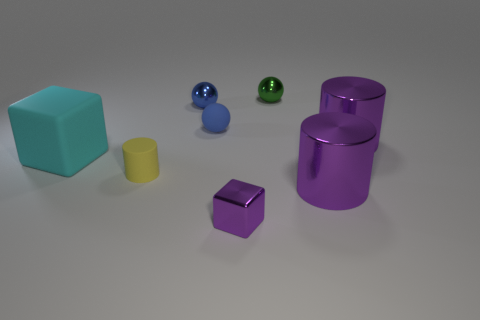Subtract all large purple cylinders. How many cylinders are left? 1 Subtract all blue balls. How many balls are left? 1 Add 1 large objects. How many objects exist? 9 Subtract all green cylinders. How many cyan cubes are left? 1 Subtract all small blue rubber spheres. Subtract all green shiny balls. How many objects are left? 6 Add 8 blue balls. How many blue balls are left? 10 Add 1 large metallic cylinders. How many large metallic cylinders exist? 3 Subtract 1 purple cubes. How many objects are left? 7 Subtract all cylinders. How many objects are left? 5 Subtract all purple cylinders. Subtract all red blocks. How many cylinders are left? 1 